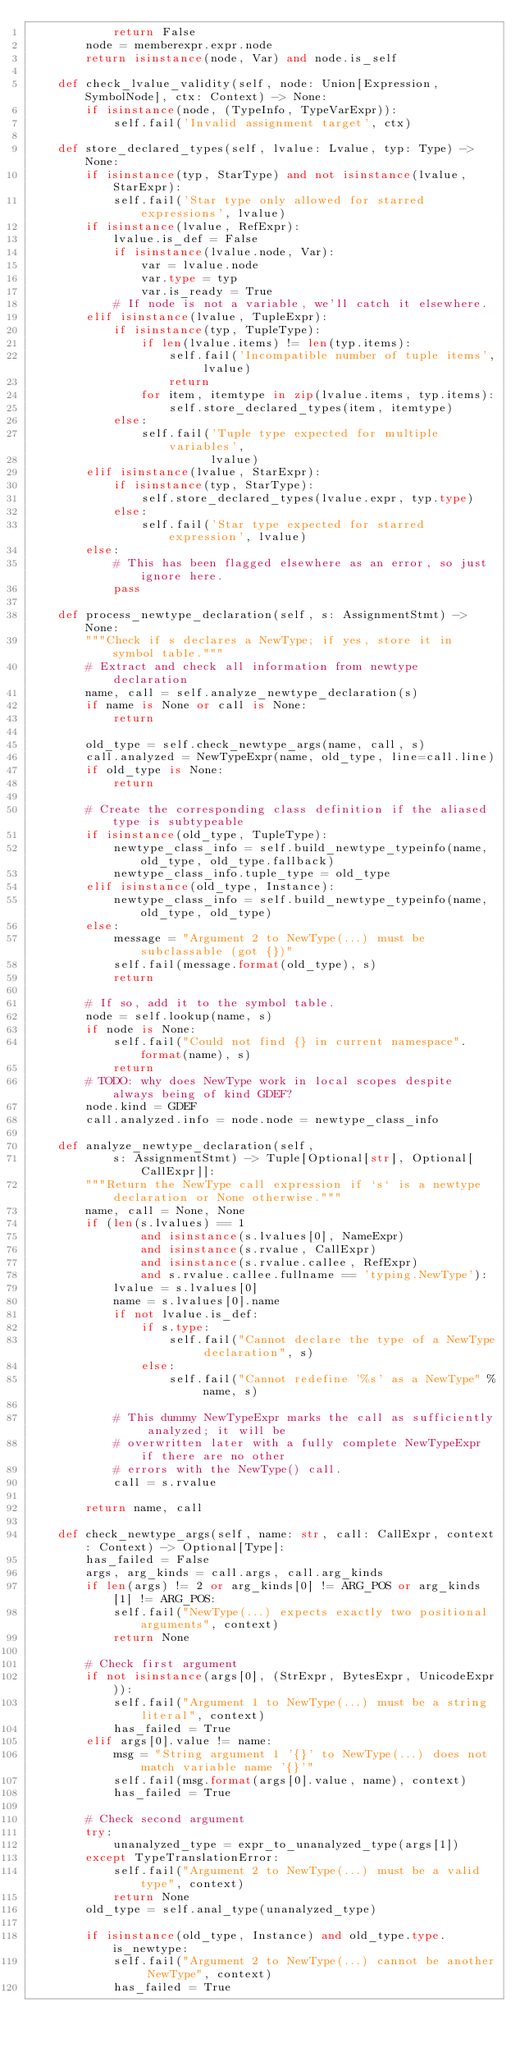<code> <loc_0><loc_0><loc_500><loc_500><_Python_>            return False
        node = memberexpr.expr.node
        return isinstance(node, Var) and node.is_self

    def check_lvalue_validity(self, node: Union[Expression, SymbolNode], ctx: Context) -> None:
        if isinstance(node, (TypeInfo, TypeVarExpr)):
            self.fail('Invalid assignment target', ctx)

    def store_declared_types(self, lvalue: Lvalue, typ: Type) -> None:
        if isinstance(typ, StarType) and not isinstance(lvalue, StarExpr):
            self.fail('Star type only allowed for starred expressions', lvalue)
        if isinstance(lvalue, RefExpr):
            lvalue.is_def = False
            if isinstance(lvalue.node, Var):
                var = lvalue.node
                var.type = typ
                var.is_ready = True
            # If node is not a variable, we'll catch it elsewhere.
        elif isinstance(lvalue, TupleExpr):
            if isinstance(typ, TupleType):
                if len(lvalue.items) != len(typ.items):
                    self.fail('Incompatible number of tuple items', lvalue)
                    return
                for item, itemtype in zip(lvalue.items, typ.items):
                    self.store_declared_types(item, itemtype)
            else:
                self.fail('Tuple type expected for multiple variables',
                          lvalue)
        elif isinstance(lvalue, StarExpr):
            if isinstance(typ, StarType):
                self.store_declared_types(lvalue.expr, typ.type)
            else:
                self.fail('Star type expected for starred expression', lvalue)
        else:
            # This has been flagged elsewhere as an error, so just ignore here.
            pass

    def process_newtype_declaration(self, s: AssignmentStmt) -> None:
        """Check if s declares a NewType; if yes, store it in symbol table."""
        # Extract and check all information from newtype declaration
        name, call = self.analyze_newtype_declaration(s)
        if name is None or call is None:
            return

        old_type = self.check_newtype_args(name, call, s)
        call.analyzed = NewTypeExpr(name, old_type, line=call.line)
        if old_type is None:
            return

        # Create the corresponding class definition if the aliased type is subtypeable
        if isinstance(old_type, TupleType):
            newtype_class_info = self.build_newtype_typeinfo(name, old_type, old_type.fallback)
            newtype_class_info.tuple_type = old_type
        elif isinstance(old_type, Instance):
            newtype_class_info = self.build_newtype_typeinfo(name, old_type, old_type)
        else:
            message = "Argument 2 to NewType(...) must be subclassable (got {})"
            self.fail(message.format(old_type), s)
            return

        # If so, add it to the symbol table.
        node = self.lookup(name, s)
        if node is None:
            self.fail("Could not find {} in current namespace".format(name), s)
            return
        # TODO: why does NewType work in local scopes despite always being of kind GDEF?
        node.kind = GDEF
        call.analyzed.info = node.node = newtype_class_info

    def analyze_newtype_declaration(self,
            s: AssignmentStmt) -> Tuple[Optional[str], Optional[CallExpr]]:
        """Return the NewType call expression if `s` is a newtype declaration or None otherwise."""
        name, call = None, None
        if (len(s.lvalues) == 1
                and isinstance(s.lvalues[0], NameExpr)
                and isinstance(s.rvalue, CallExpr)
                and isinstance(s.rvalue.callee, RefExpr)
                and s.rvalue.callee.fullname == 'typing.NewType'):
            lvalue = s.lvalues[0]
            name = s.lvalues[0].name
            if not lvalue.is_def:
                if s.type:
                    self.fail("Cannot declare the type of a NewType declaration", s)
                else:
                    self.fail("Cannot redefine '%s' as a NewType" % name, s)

            # This dummy NewTypeExpr marks the call as sufficiently analyzed; it will be
            # overwritten later with a fully complete NewTypeExpr if there are no other
            # errors with the NewType() call.
            call = s.rvalue

        return name, call

    def check_newtype_args(self, name: str, call: CallExpr, context: Context) -> Optional[Type]:
        has_failed = False
        args, arg_kinds = call.args, call.arg_kinds
        if len(args) != 2 or arg_kinds[0] != ARG_POS or arg_kinds[1] != ARG_POS:
            self.fail("NewType(...) expects exactly two positional arguments", context)
            return None

        # Check first argument
        if not isinstance(args[0], (StrExpr, BytesExpr, UnicodeExpr)):
            self.fail("Argument 1 to NewType(...) must be a string literal", context)
            has_failed = True
        elif args[0].value != name:
            msg = "String argument 1 '{}' to NewType(...) does not match variable name '{}'"
            self.fail(msg.format(args[0].value, name), context)
            has_failed = True

        # Check second argument
        try:
            unanalyzed_type = expr_to_unanalyzed_type(args[1])
        except TypeTranslationError:
            self.fail("Argument 2 to NewType(...) must be a valid type", context)
            return None
        old_type = self.anal_type(unanalyzed_type)

        if isinstance(old_type, Instance) and old_type.type.is_newtype:
            self.fail("Argument 2 to NewType(...) cannot be another NewType", context)
            has_failed = True
</code> 